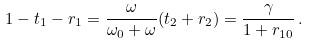Convert formula to latex. <formula><loc_0><loc_0><loc_500><loc_500>1 - t _ { 1 } - r _ { 1 } = \frac { \omega } { \omega _ { 0 } + \omega } ( t _ { 2 } + r _ { 2 } ) = \frac { \gamma } { 1 + r _ { 1 0 } } \, .</formula> 